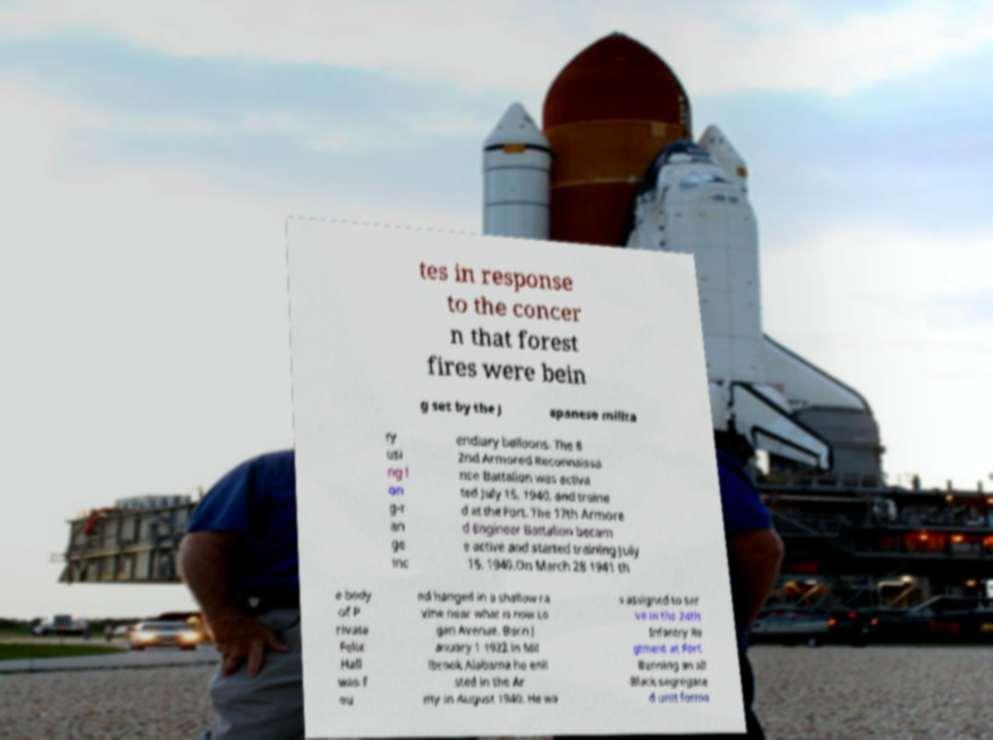I need the written content from this picture converted into text. Can you do that? tes in response to the concer n that forest fires were bein g set by the J apanese milita ry usi ng l on g-r an ge inc endiary balloons. The 8 2nd Armored Reconnaissa nce Battalion was activa ted July 15, 1940, and traine d at the Fort. The 17th Armore d Engineer Battalion becam e active and started training July 15, 1940.On March 28 1941 th e body of P rivate Felix Hall was f ou nd hanged in a shallow ra vine near what is now Lo gan Avenue. Born J anuary 1 1922 in Mil lbrook Alabama he enli sted in the Ar my in August 1940. He wa s assigned to ser ve in the 24th Infantry Re giment at Fort Benning an all -Black segregate d unit forme 